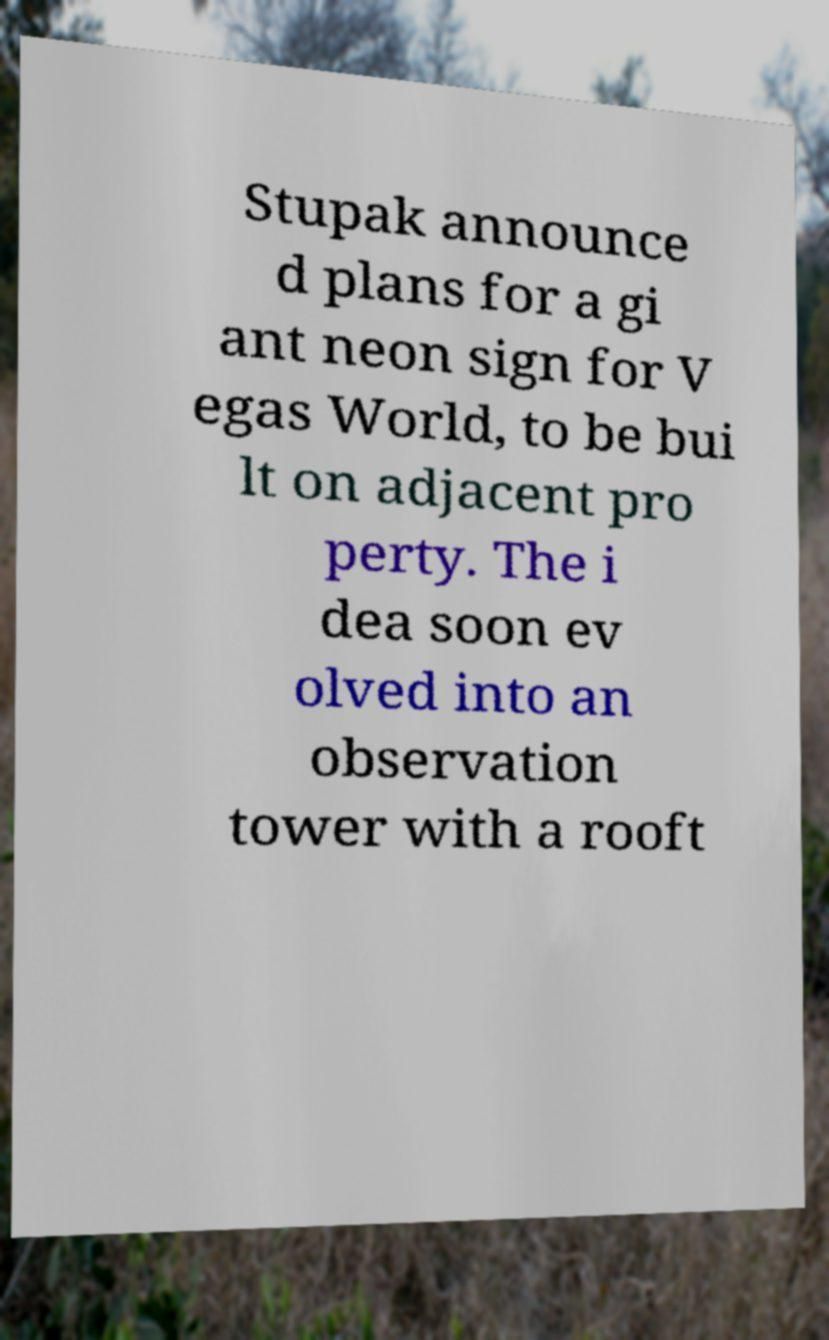Please identify and transcribe the text found in this image. Stupak announce d plans for a gi ant neon sign for V egas World, to be bui lt on adjacent pro perty. The i dea soon ev olved into an observation tower with a rooft 